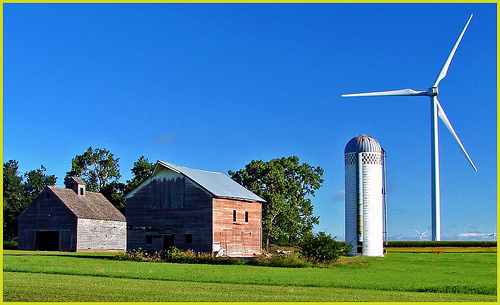<image>
Is there a barn next to the windmill? Yes. The barn is positioned adjacent to the windmill, located nearby in the same general area. 